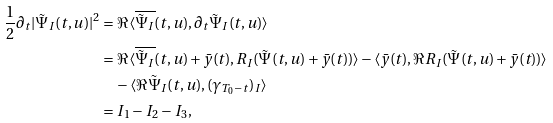Convert formula to latex. <formula><loc_0><loc_0><loc_500><loc_500>\frac { 1 } { 2 } \partial _ { t } | \tilde { \Psi } _ { I } ( t , u ) | ^ { 2 } & = \Re \langle \overline { \tilde { \Psi } _ { I } } ( t , u ) , \partial _ { t } \tilde { \Psi } _ { I } ( t , u ) \rangle \\ & = \Re \langle \overline { \tilde { \Psi } _ { I } } ( t , u ) + \bar { y } ( t ) , R _ { I } ( \tilde { \Psi } ( t , u ) + \bar { y } ( t ) ) \rangle - \langle \bar { y } ( t ) , \Re R _ { I } ( \tilde { \Psi } ( t , u ) + \bar { y } ( t ) ) \rangle \\ & \quad - \langle \Re \tilde { \Psi } _ { I } ( t , u ) , ( \gamma _ { T _ { 0 } - t } ) _ { I } \rangle \\ & = I _ { 1 } - I _ { 2 } - I _ { 3 } ,</formula> 